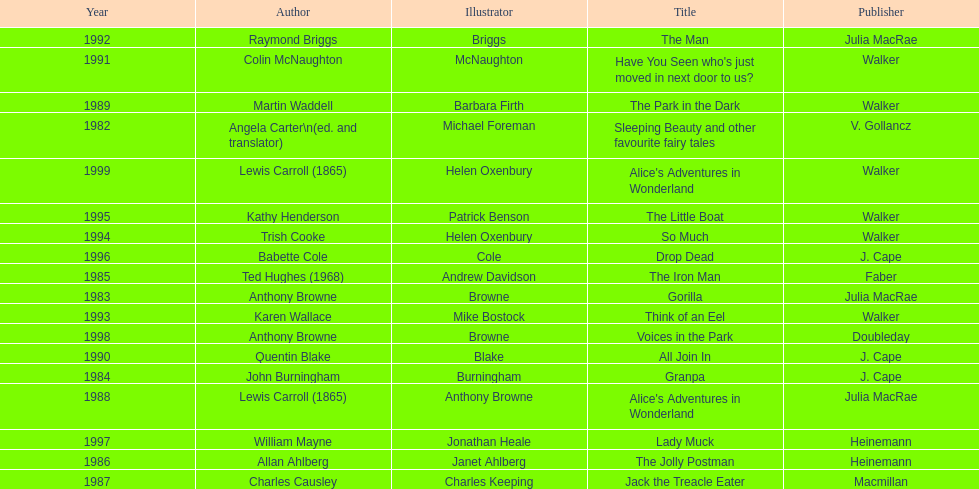What's the difference in years between angela carter's title and anthony browne's? 1. 